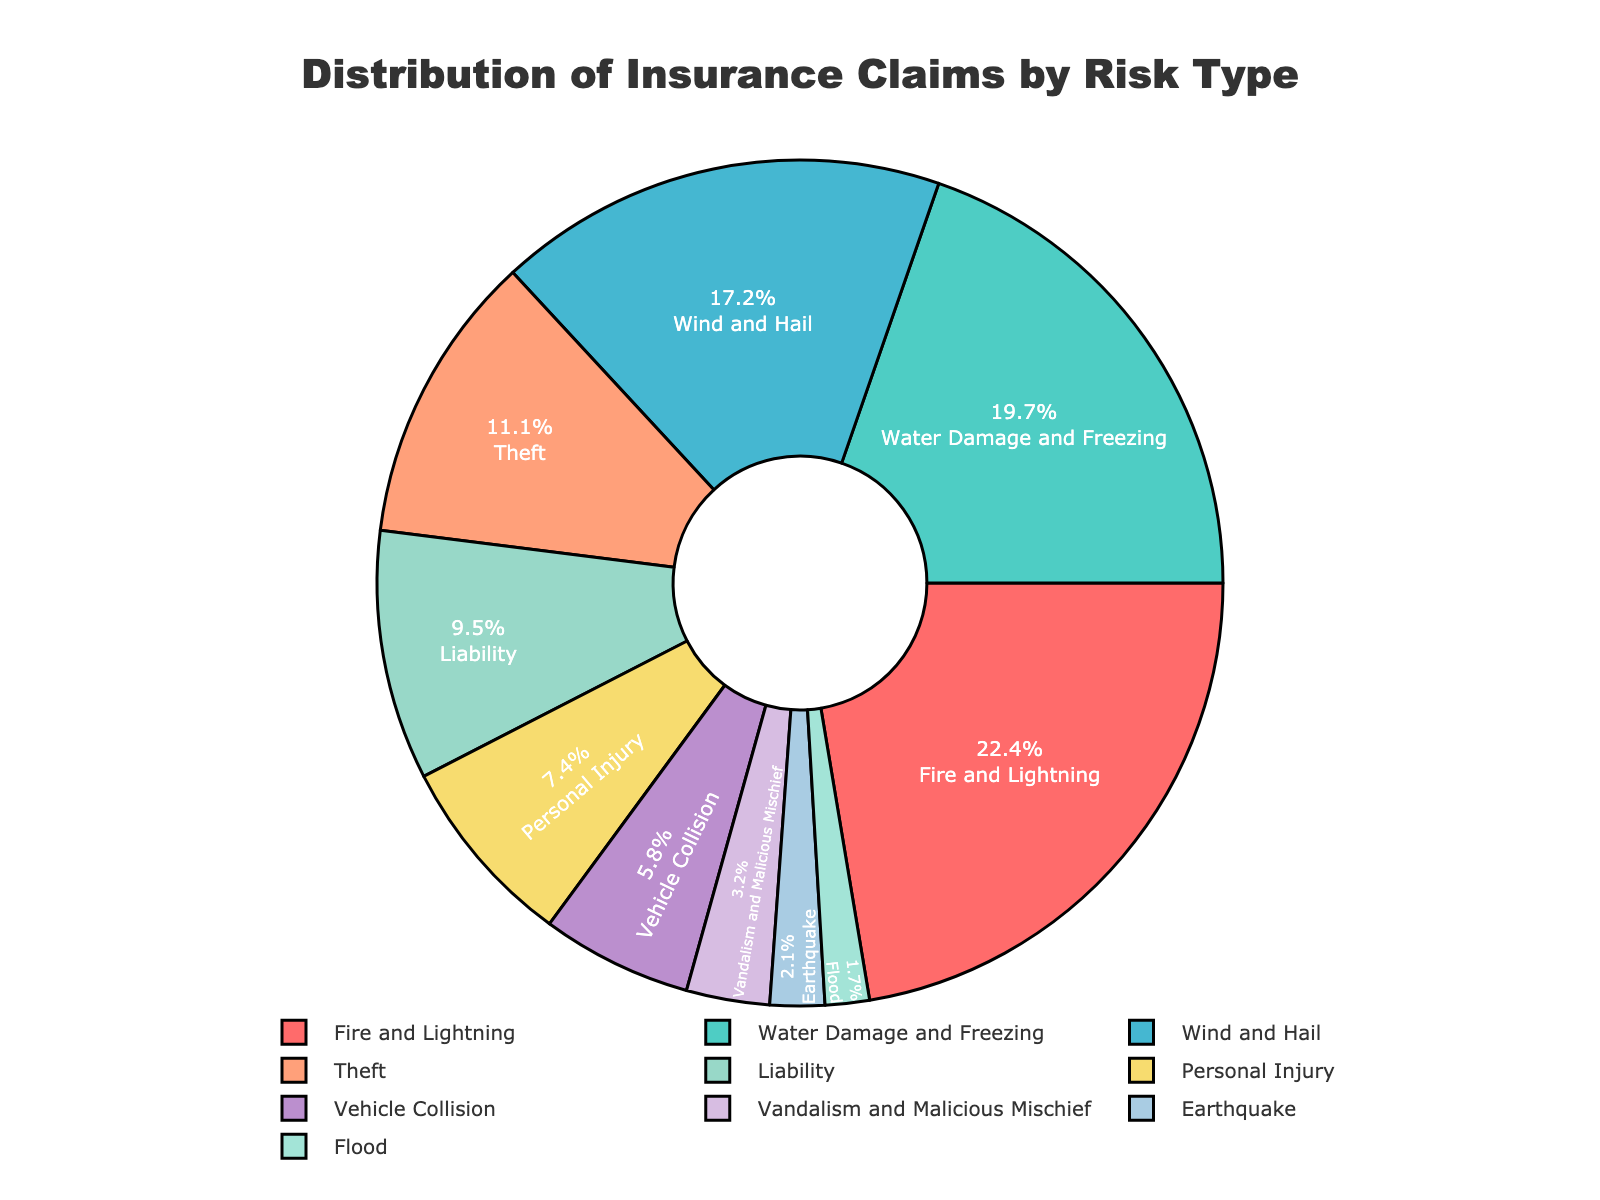What percentage of insurance claims are attributed to Fire and Lightning? Locate the section of the pie chart labeled "Fire and Lightning" which is one of the largest sections. The percentage shown within that section is 22.5%.
Answer: 22.5% How do the claims for Water Damage and Freezing compare to those for Theft? Find the sections of the pie chart labeled "Water Damage and Freezing" and "Theft". Water Damage and Freezing have 19.8%, while Theft has 11.2%. 19.8% is greater than 11.2%.
Answer: Water Damage and Freezing claims are greater than Theft claims What is the total percentage of claims for Wind and Hail, and Personal Injury combined? Identify the percentages for "Wind and Hail" and "Personal Injury" from the pie chart, which are 17.3% and 7.4% respectively. Add these two values: 17.3% + 7.4% = 24.7%.
Answer: 24.7% Which type of risk has the smallest percentage of insurance claims? Look for the smallest section of the pie chart. The smallest section is labeled "Flood" with a percentage of 1.7%.
Answer: Flood By what margin do Fire and Lightning claims exceed Vehicle Collision claims? Locate the percentages for "Fire and Lightning" (22.5%) and "Vehicle Collision" (5.8%) in the pie chart. Subtract the smaller percentage from the larger percentage: 22.5% - 5.8% = 16.7%.
Answer: 16.7% Is the percentage of claims for Earthquake higher or lower than that for Vandalism and Malicious Mischief? Identify the sections labeled "Earthquake" and "Vandalism and Malicious Mischief". Earthquake claims are 2.1% while Vandalism and Malicious Mischief claims are 3.2%. 2.1% is lower than 3.2%.
Answer: Lower What is the difference between the percentages for Liability and Personal Injury claims? Find the percentages for "Liability" (9.6%) and "Personal Injury" (7.4%) in the pie chart. Subtract the smaller percentage from the larger percentage: 9.6% - 7.4% = 2.2%.
Answer: 2.2% Which type of risk is associated with a green shade in the pie chart, and what is their claim percentage? Notice the section of the pie chart with a green shade. This corresponds to "Water Damage and Freezing", and the percentage indicated is 19.8%.
Answer: Water Damage and Freezing, 19.8% What is the combined percentage of claims for theft, personal injury, and vehicle collision? Locate the percentages for "Theft" (11.2%), "Personal Injury" (7.4%), and "Vehicle Collision" (5.8%). Sum these values: 11.2% + 7.4% + 5.8% = 24.4%.
Answer: 24.4% Which types of risk collectively account for approximately half of all claims? Identify the largest sections of the pie chart and sum their percentages. Sum the top claims: "Fire and Lightning" (22.5%), "Water Damage and Freezing" (19.8%), and "Wind and Hail" (17.3%). Adding these gives 22.5% + 19.8% + 17.3% = 59.6%, which is more than half.
Answer: Fire and Lightning, Water Damage and Freezing, Wind and Hail 